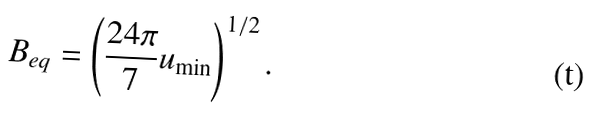Convert formula to latex. <formula><loc_0><loc_0><loc_500><loc_500>B _ { e q } = \left ( \frac { 2 4 \pi } { 7 } u _ { \min } \right ) ^ { 1 / 2 } .</formula> 